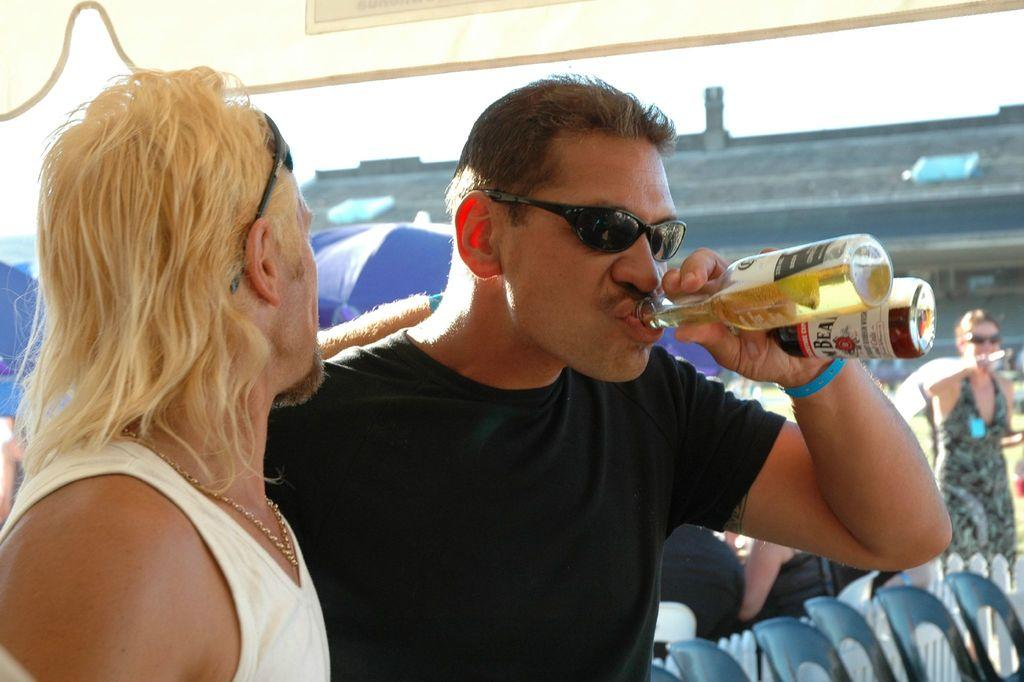How many people are the number of people in the image? There are two men in the image. What are the two men doing in the image? The two men are drinking wine. Can you describe the interaction between the people in the image? There is a person in the image who is staring at someone else. What type of sky can be seen in the image? There is no sky visible in the image; it is focused on the two men drinking wine and their interaction. Can you tell me how many fowls are present in the image? There are no fowls present in the image. 